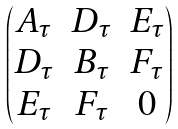Convert formula to latex. <formula><loc_0><loc_0><loc_500><loc_500>\begin{pmatrix} A _ { \tau } & D _ { \tau } & E _ { \tau } \\ D _ { \tau } & B _ { \tau } & F _ { \tau } \\ E _ { \tau } & F _ { \tau } & 0 \end{pmatrix}</formula> 